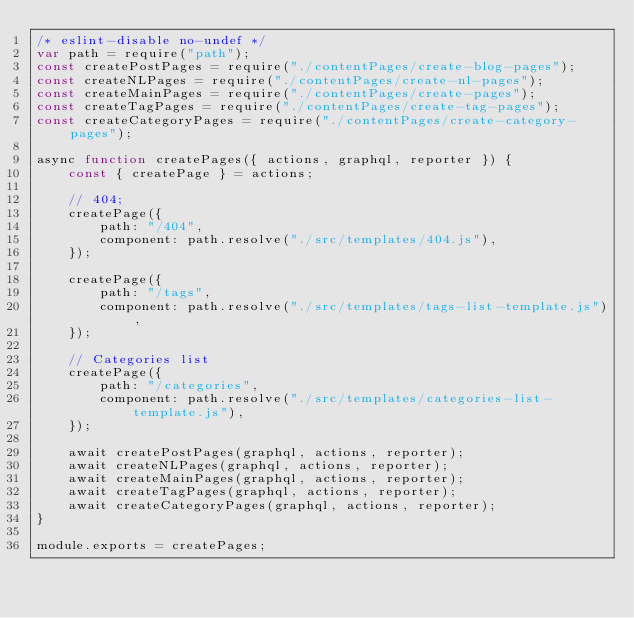<code> <loc_0><loc_0><loc_500><loc_500><_JavaScript_>/* eslint-disable no-undef */
var path = require("path");
const createPostPages = require("./contentPages/create-blog-pages");
const createNLPages = require("./contentPages/create-nl-pages");
const createMainPages = require("./contentPages/create-pages");
const createTagPages = require("./contentPages/create-tag-pages");
const createCategoryPages = require("./contentPages/create-category-pages");

async function createPages({ actions, graphql, reporter }) {
    const { createPage } = actions;

    // 404;
    createPage({
        path: "/404",
        component: path.resolve("./src/templates/404.js"),
    });

    createPage({
        path: "/tags",
        component: path.resolve("./src/templates/tags-list-template.js"),
    });

    // Categories list
    createPage({
        path: "/categories",
        component: path.resolve("./src/templates/categories-list-template.js"),
    });

    await createPostPages(graphql, actions, reporter);
    await createNLPages(graphql, actions, reporter);
    await createMainPages(graphql, actions, reporter);
    await createTagPages(graphql, actions, reporter);
    await createCategoryPages(graphql, actions, reporter);
}

module.exports = createPages;
</code> 